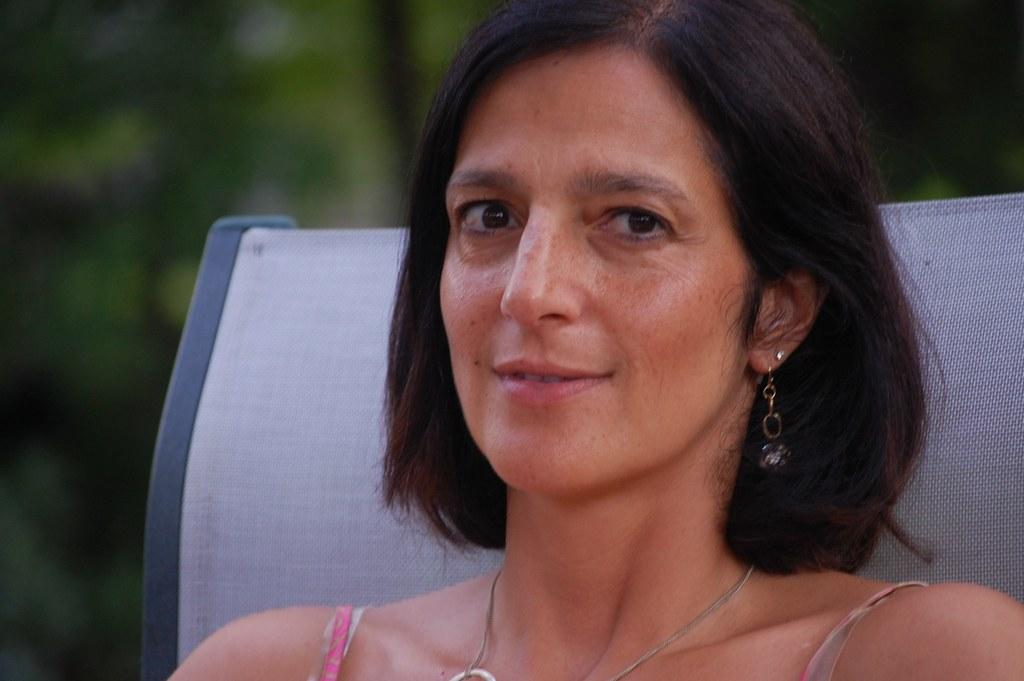Who is present in the image? There is a woman in the image. What is the woman's facial expression? The woman is smiling. Can you describe the object behind the woman? Unfortunately, the background of the image is blurry, so it is difficult to make out the object behind the woman. What type of comb is the woman using to groom the insect in the image? There is no comb or insect present in the image. 